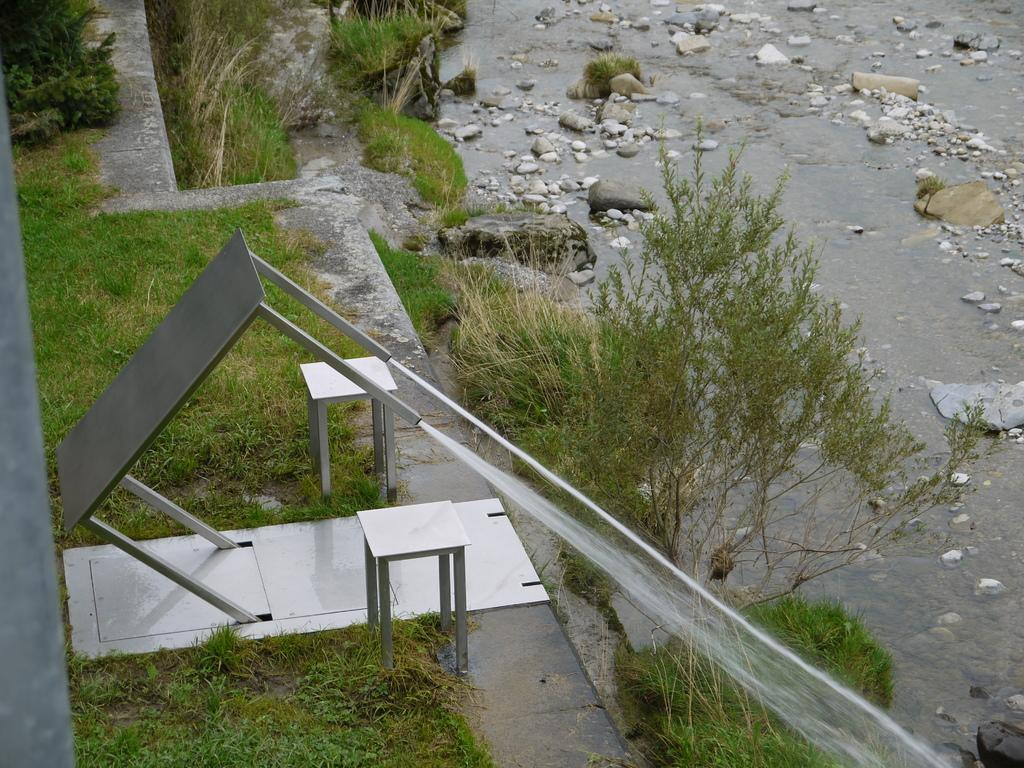What type of vegetation can be seen in the image? There are trees in the image. What other objects are present in the image? There are stones and iron stools visible in the image. What can be seen in the background of the image? There is water visible in the image. How many pairs of shoes can be seen in the image? There are no shoes present in the image. Are there any snakes visible in the image? There are no snakes present in the image. 